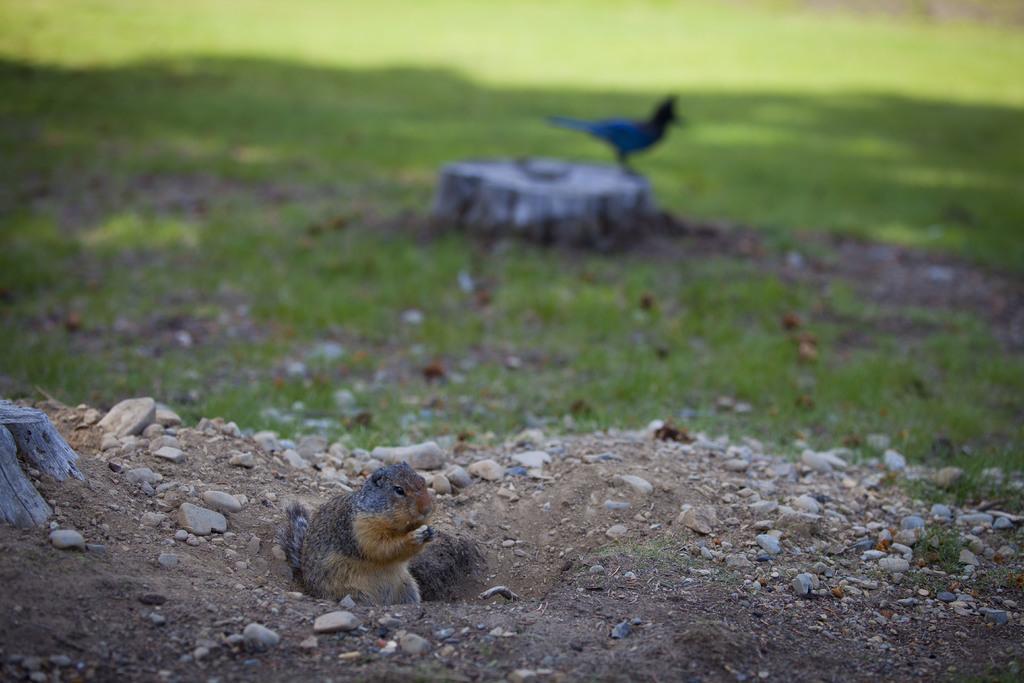Can you describe this image briefly? This picture consists of a bird and a squirrel and some stones and grass visible in the middle. 